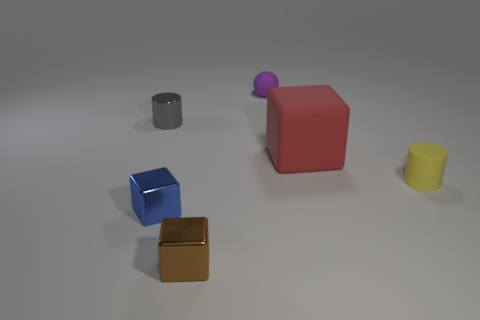How many things are either cylinders to the right of the small brown block or metallic blocks?
Give a very brief answer. 3. The gray object that is made of the same material as the blue block is what shape?
Your answer should be compact. Cylinder. The small blue metal thing is what shape?
Your answer should be compact. Cube. The block that is both on the right side of the blue metal cube and in front of the big matte thing is what color?
Provide a succinct answer. Brown. What is the shape of the purple matte object that is the same size as the brown metal block?
Provide a succinct answer. Sphere. Are there any other tiny metallic things that have the same shape as the tiny blue metal object?
Provide a succinct answer. Yes. Does the tiny brown cube have the same material as the cylinder on the left side of the small blue cube?
Keep it short and to the point. Yes. The cylinder in front of the tiny metal thing that is behind the tiny matte object that is in front of the red block is what color?
Ensure brevity in your answer.  Yellow. What is the material of the gray object that is the same size as the matte sphere?
Offer a terse response. Metal. How many large objects are made of the same material as the tiny ball?
Ensure brevity in your answer.  1. 